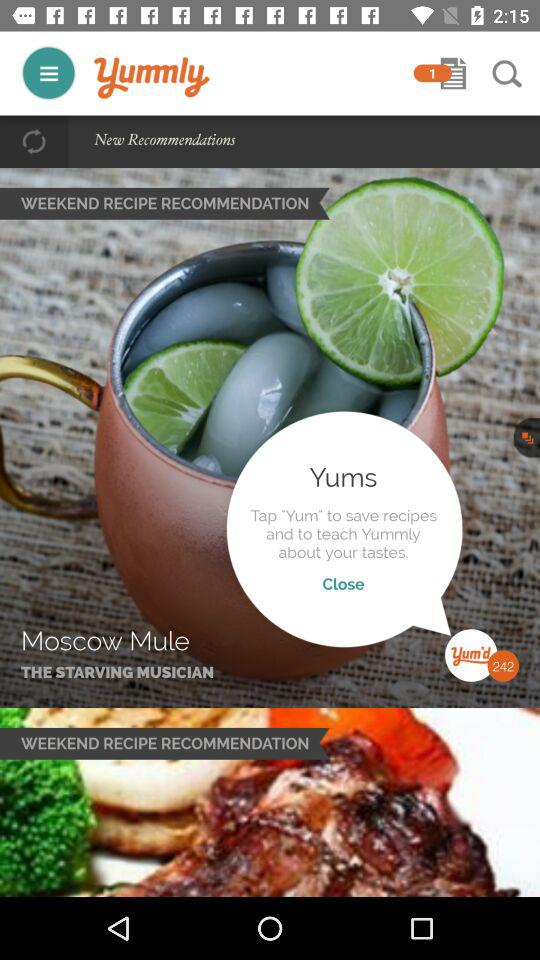What is the name of the application? The application name is "yummly". 